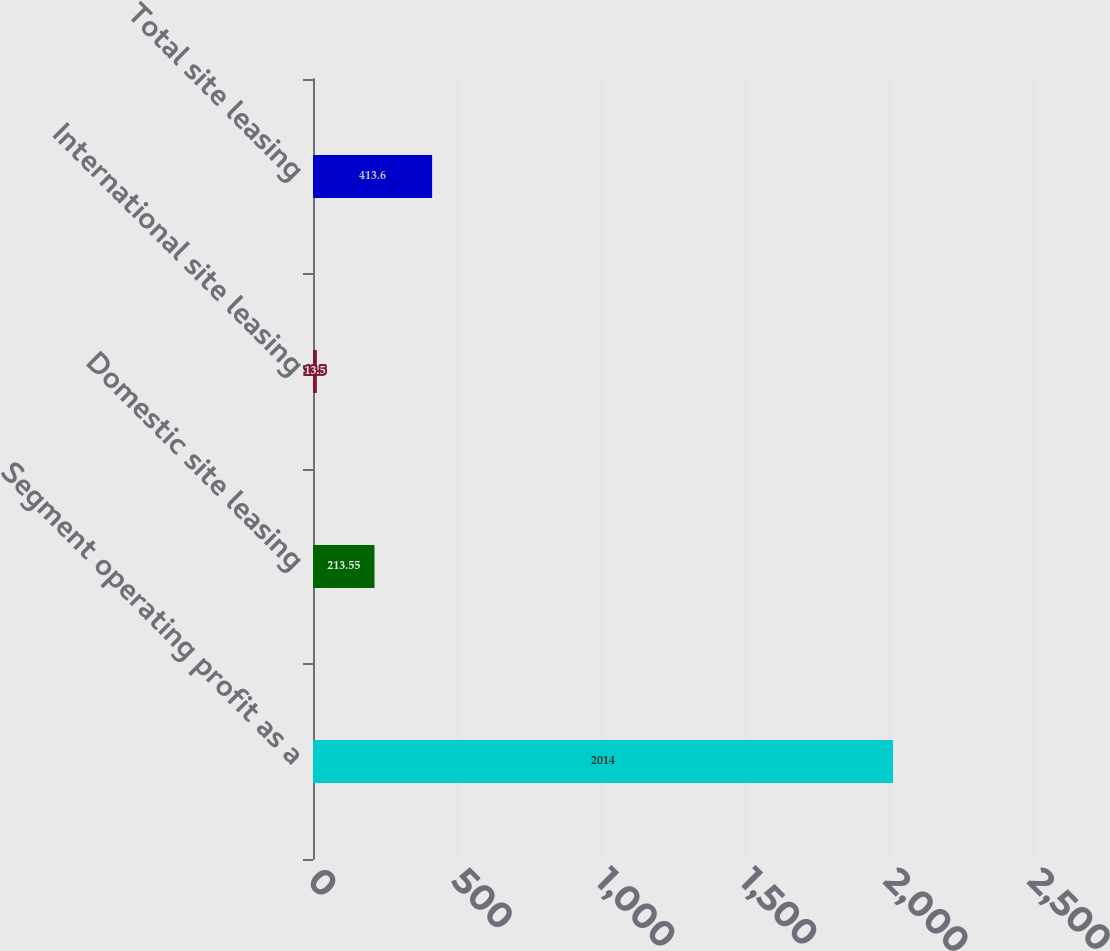Convert chart to OTSL. <chart><loc_0><loc_0><loc_500><loc_500><bar_chart><fcel>Segment operating profit as a<fcel>Domestic site leasing<fcel>International site leasing<fcel>Total site leasing<nl><fcel>2014<fcel>213.55<fcel>13.5<fcel>413.6<nl></chart> 